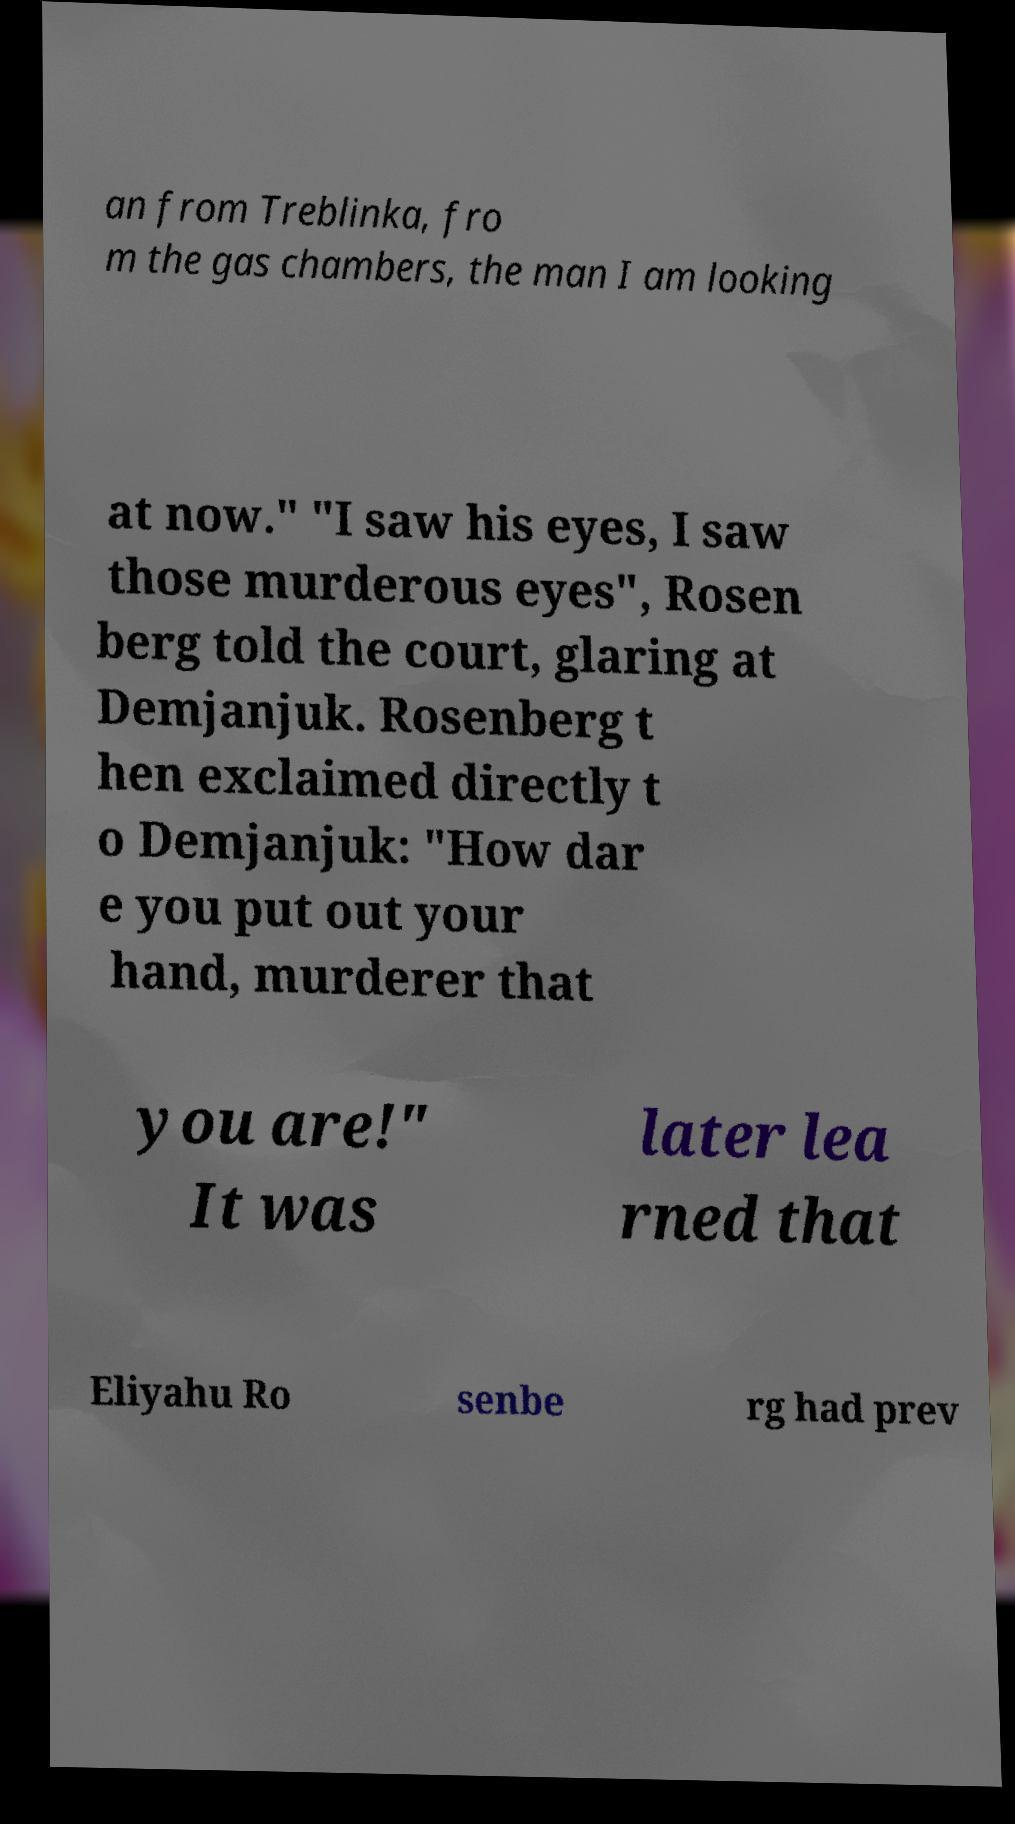Please identify and transcribe the text found in this image. an from Treblinka, fro m the gas chambers, the man I am looking at now." "I saw his eyes, I saw those murderous eyes", Rosen berg told the court, glaring at Demjanjuk. Rosenberg t hen exclaimed directly t o Demjanjuk: "How dar e you put out your hand, murderer that you are!" It was later lea rned that Eliyahu Ro senbe rg had prev 